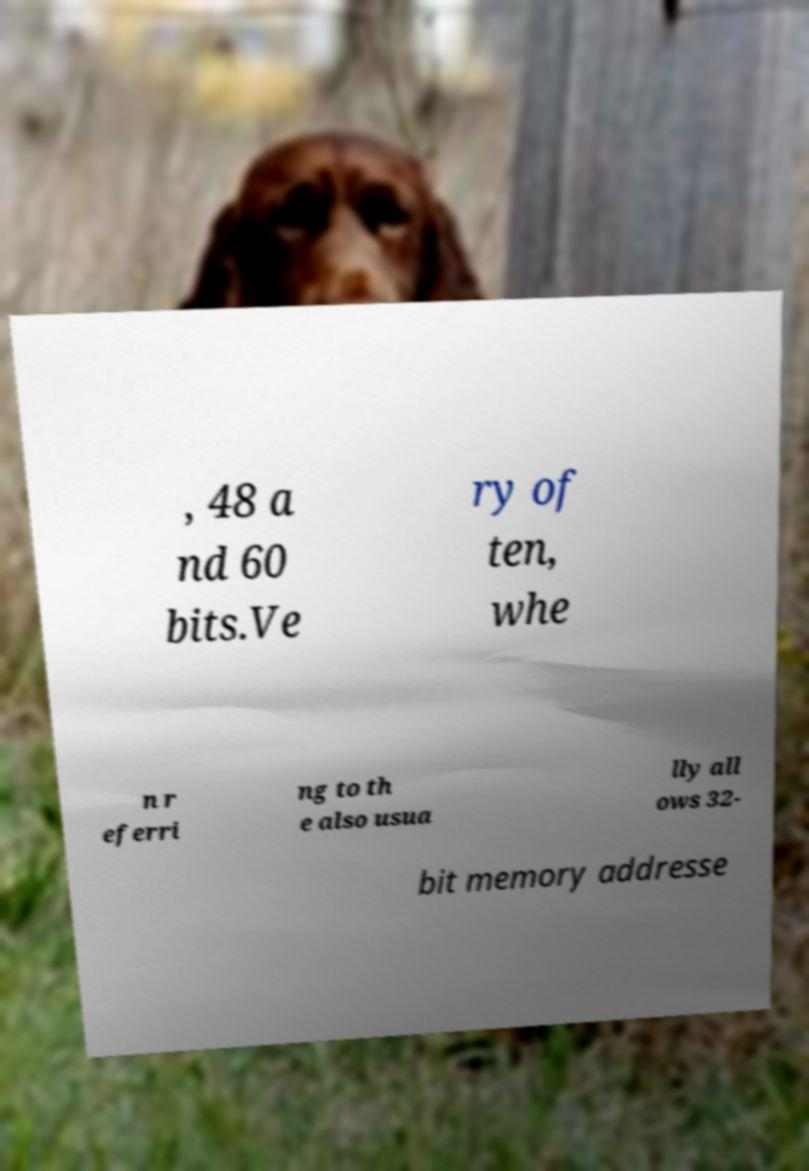Can you read and provide the text displayed in the image?This photo seems to have some interesting text. Can you extract and type it out for me? , 48 a nd 60 bits.Ve ry of ten, whe n r eferri ng to th e also usua lly all ows 32- bit memory addresse 